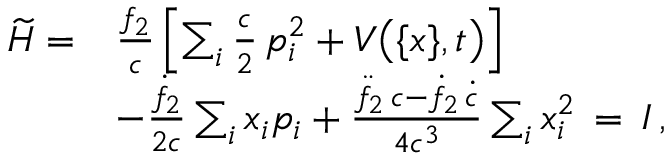Convert formula to latex. <formula><loc_0><loc_0><loc_500><loc_500>\begin{array} { r l } { \widetilde { H } = } & { \frac { f _ { 2 } } { c } \left [ \sum _ { i } \frac { c } { 2 } \, p _ { i } ^ { 2 } + V \left ( \{ x \} , t \right ) \right ] } \\ & { - \frac { \dot { f } _ { 2 } } { 2 c } \sum _ { i } x _ { i } p _ { i } + \frac { \ddot { f } _ { 2 } \, c - \dot { f } _ { 2 } \, \dot { c } } { 4 c ^ { 3 } } \sum _ { i } x _ { i } ^ { 2 } \, = \, I \, , } \end{array}</formula> 